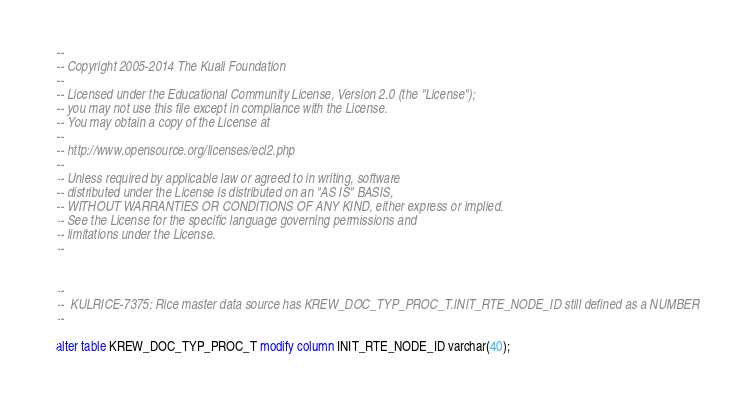<code> <loc_0><loc_0><loc_500><loc_500><_SQL_>--
-- Copyright 2005-2014 The Kuali Foundation
--
-- Licensed under the Educational Community License, Version 2.0 (the "License");
-- you may not use this file except in compliance with the License.
-- You may obtain a copy of the License at
--
-- http://www.opensource.org/licenses/ecl2.php
--
-- Unless required by applicable law or agreed to in writing, software
-- distributed under the License is distributed on an "AS IS" BASIS,
-- WITHOUT WARRANTIES OR CONDITIONS OF ANY KIND, either express or implied.
-- See the License for the specific language governing permissions and
-- limitations under the License.
--


--
--  KULRICE-7375: Rice master data source has KREW_DOC_TYP_PROC_T.INIT_RTE_NODE_ID still defined as a NUMBER
--

alter table KREW_DOC_TYP_PROC_T modify column INIT_RTE_NODE_ID varchar(40);</code> 